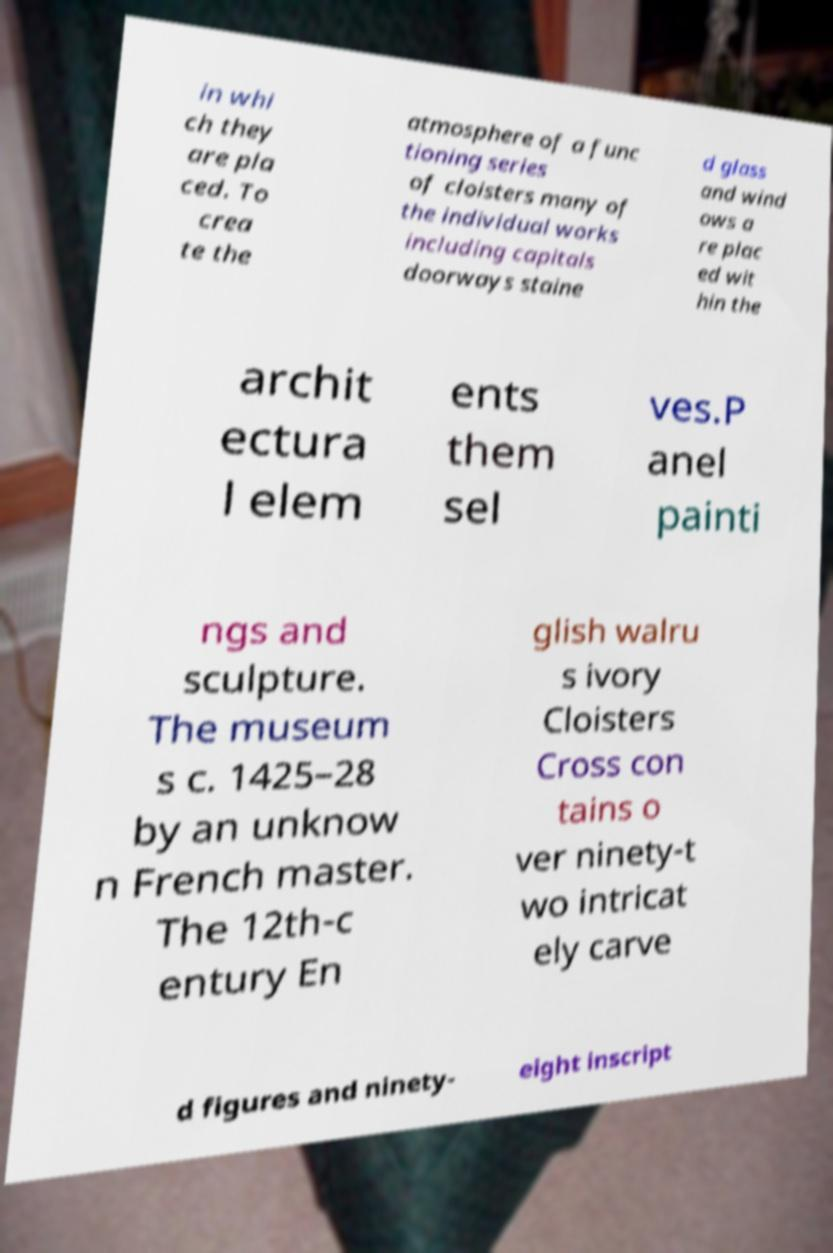Could you assist in decoding the text presented in this image and type it out clearly? in whi ch they are pla ced. To crea te the atmosphere of a func tioning series of cloisters many of the individual works including capitals doorways staine d glass and wind ows a re plac ed wit hin the archit ectura l elem ents them sel ves.P anel painti ngs and sculpture. The museum s c. 1425–28 by an unknow n French master. The 12th-c entury En glish walru s ivory Cloisters Cross con tains o ver ninety-t wo intricat ely carve d figures and ninety- eight inscript 